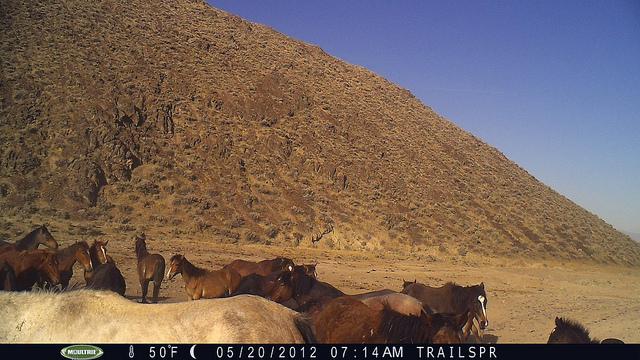Is it a cold day?
Answer briefly. No. What is in the background?
Write a very short answer. Mountain. What type of terrain is the horses on?
Answer briefly. Dirt. Do these horses have on saddles?
Quick response, please. No. How many horses are facing towards the camera?
Concise answer only. 3. 